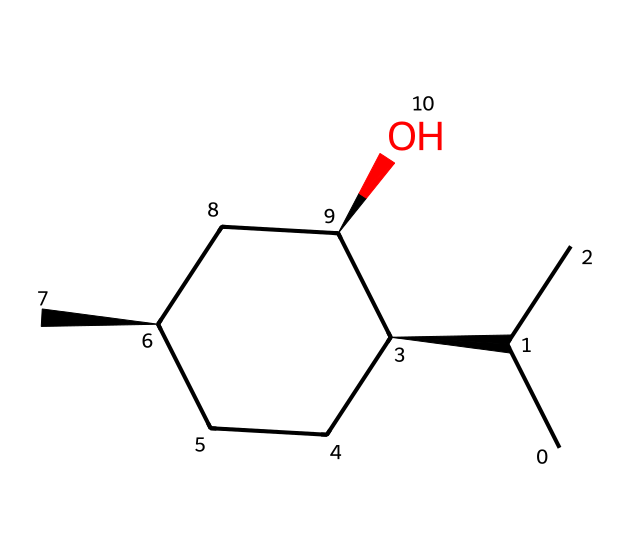how many chiral centers are in this compound? To determine the number of chiral centers in this compound, we look for carbon atoms that are bonded to four different groups. In the SMILES representation provided, there are three carbon atoms marked with @ and @@, indicating they are chiral centers.
Answer: three what is the molecular formula of menthol? The molecular formula can be derived from counting the types of atoms present in the structure. From the SMILES representation, we identify 10 carbon atoms (C), 20 hydrogen atoms (H), and 1 oxygen atom (O). Thus, the molecular formula is C10H20O.
Answer: C10H20O what type of alcohol is menthol classified as? Menthol contains a hydroxyl group (–OH) attached to its carbon structure, classifying it as a primary alcohol since the hydroxyl group is bonded to a carbon atom that is attached to only one other carbon atom.
Answer: primary alcohol which specific property of menthol is influenced by its chiral structure? The chiral structure of menthol impacts its sensory properties, particularly its minty flavor and cooling sensation. This structural asymmetry leads to different interactions with receptors in the mouth and skin, causing these sensory effects.
Answer: cooling sensation how does the presence of chiral centers affect menthol's behavior in a biological system? Chiral centers result in enantiomers that can have different biological activities and interactions within the body. In the case of menthol, its specific enantiomer interacts differently with biochemical receptors, which can influence effects such as analgesia and flavor perception.
Answer: different biological activities 